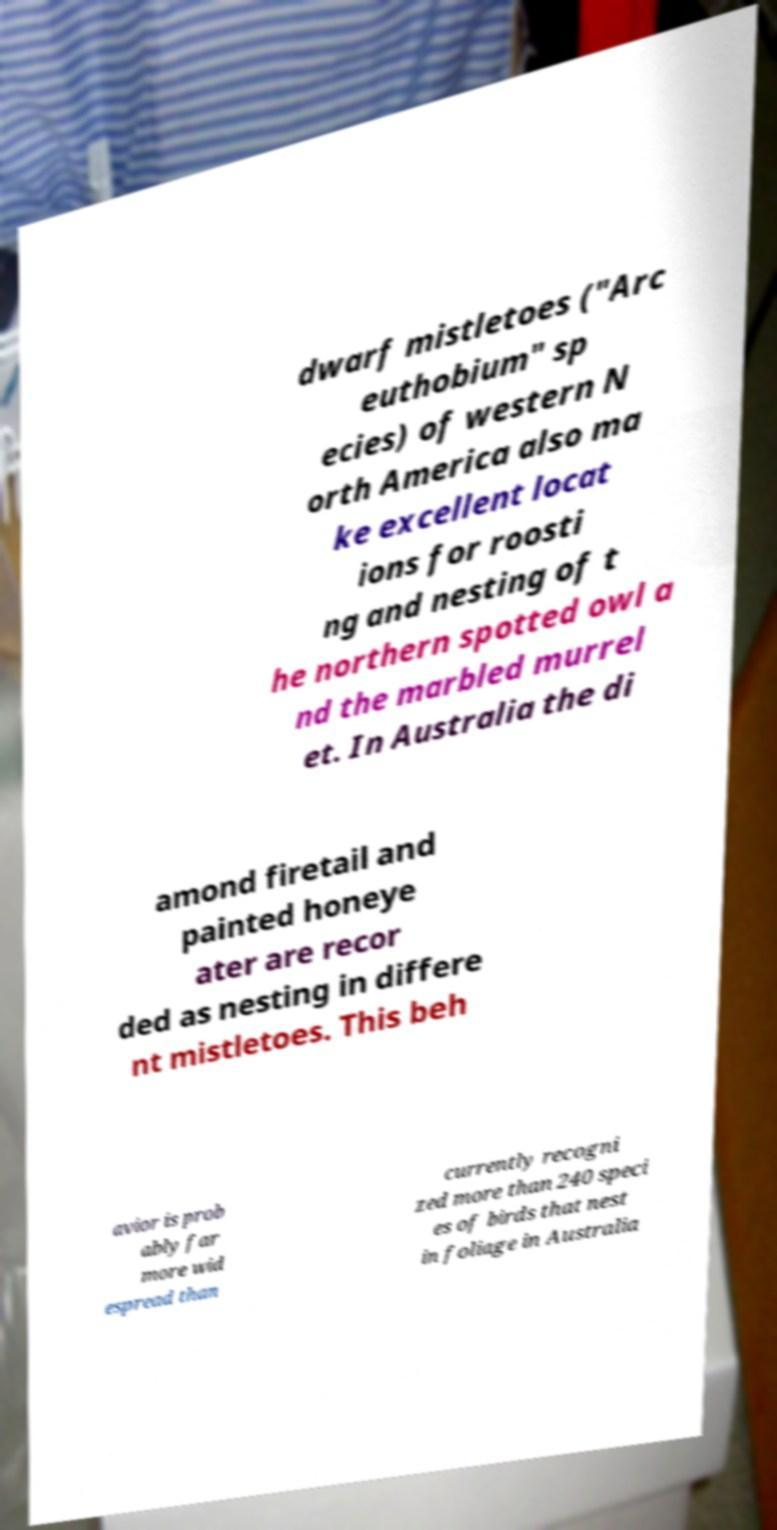There's text embedded in this image that I need extracted. Can you transcribe it verbatim? dwarf mistletoes ("Arc euthobium" sp ecies) of western N orth America also ma ke excellent locat ions for roosti ng and nesting of t he northern spotted owl a nd the marbled murrel et. In Australia the di amond firetail and painted honeye ater are recor ded as nesting in differe nt mistletoes. This beh avior is prob ably far more wid espread than currently recogni zed more than 240 speci es of birds that nest in foliage in Australia 